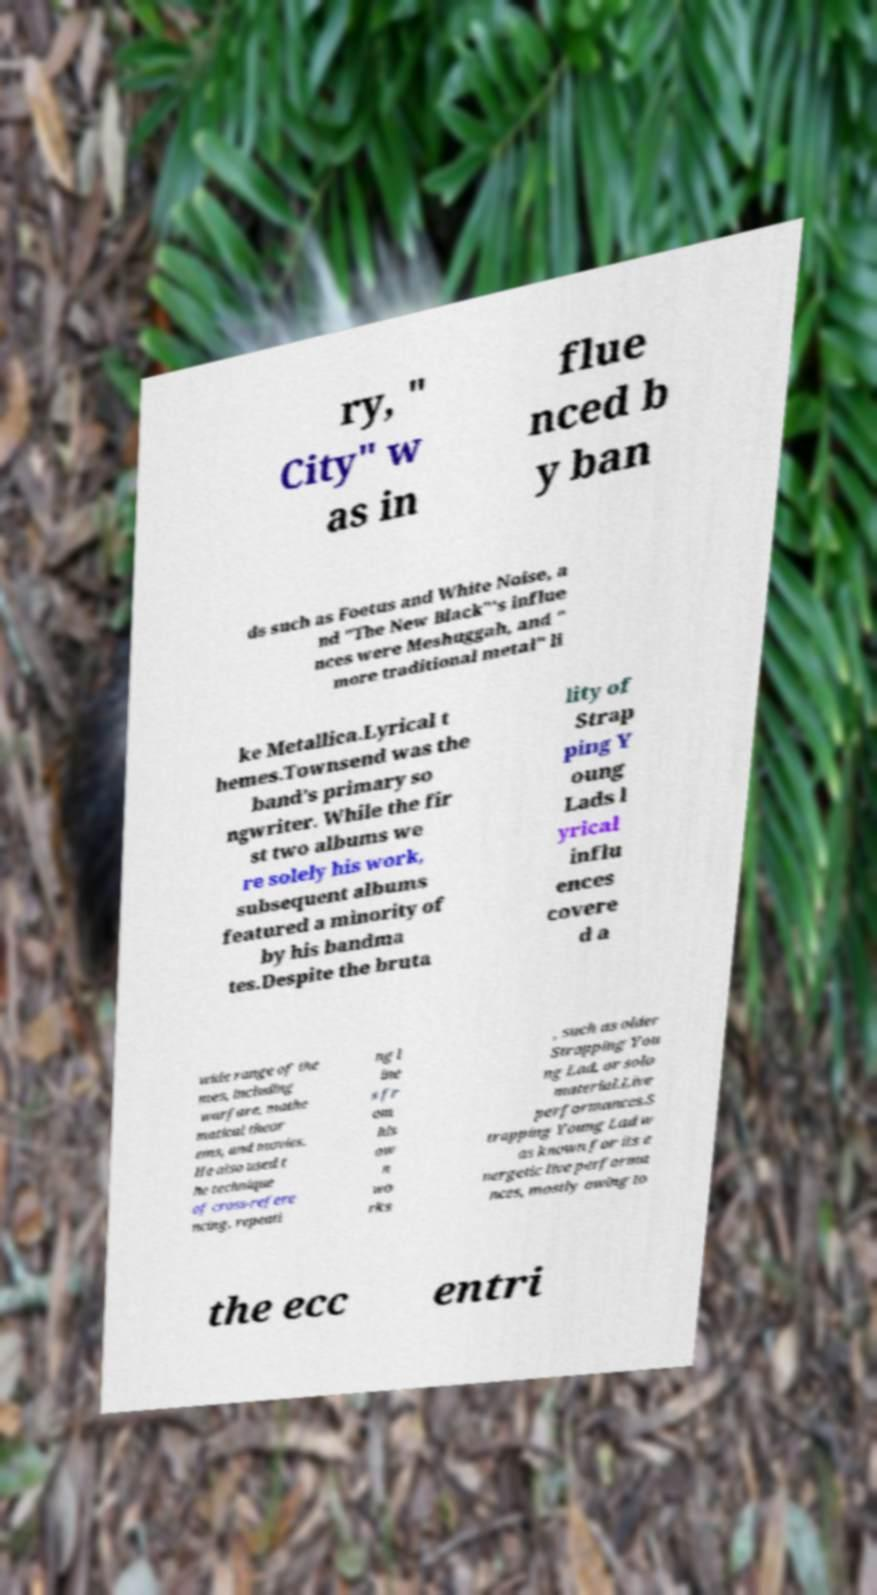Could you assist in decoding the text presented in this image and type it out clearly? ry, " City" w as in flue nced b y ban ds such as Foetus and White Noise, a nd "The New Black"'s influe nces were Meshuggah, and " more traditional metal" li ke Metallica.Lyrical t hemes.Townsend was the band's primary so ngwriter. While the fir st two albums we re solely his work, subsequent albums featured a minority of by his bandma tes.Despite the bruta lity of Strap ping Y oung Lads l yrical influ ences covere d a wide range of the mes, including warfare, mathe matical theor ems, and movies. He also used t he technique of cross-refere ncing, repeati ng l ine s fr om his ow n wo rks , such as older Strapping You ng Lad, or solo material.Live performances.S trapping Young Lad w as known for its e nergetic live performa nces, mostly owing to the ecc entri 